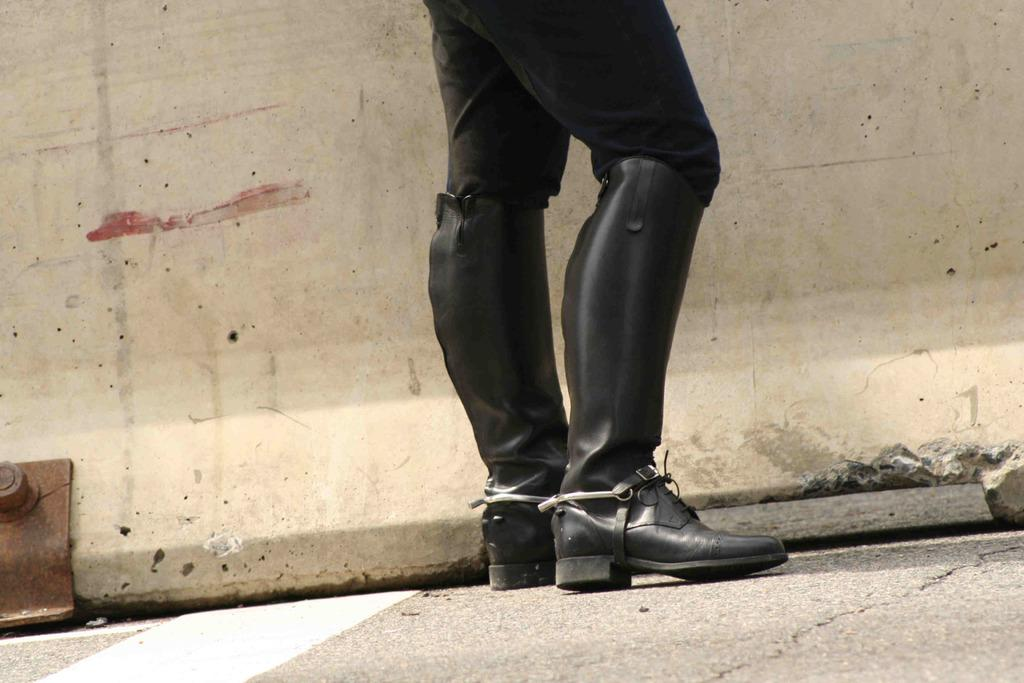What is the main subject in the image? There is a person standing in the image. Where is the person standing? The person is standing on the floor. What can be seen in the background of the image? There is a wall visible in the image. Can you see a gate leading to the seashore in the image? There is no gate or seashore present in the image; it only features a person standing on the floor with a wall in the background. 